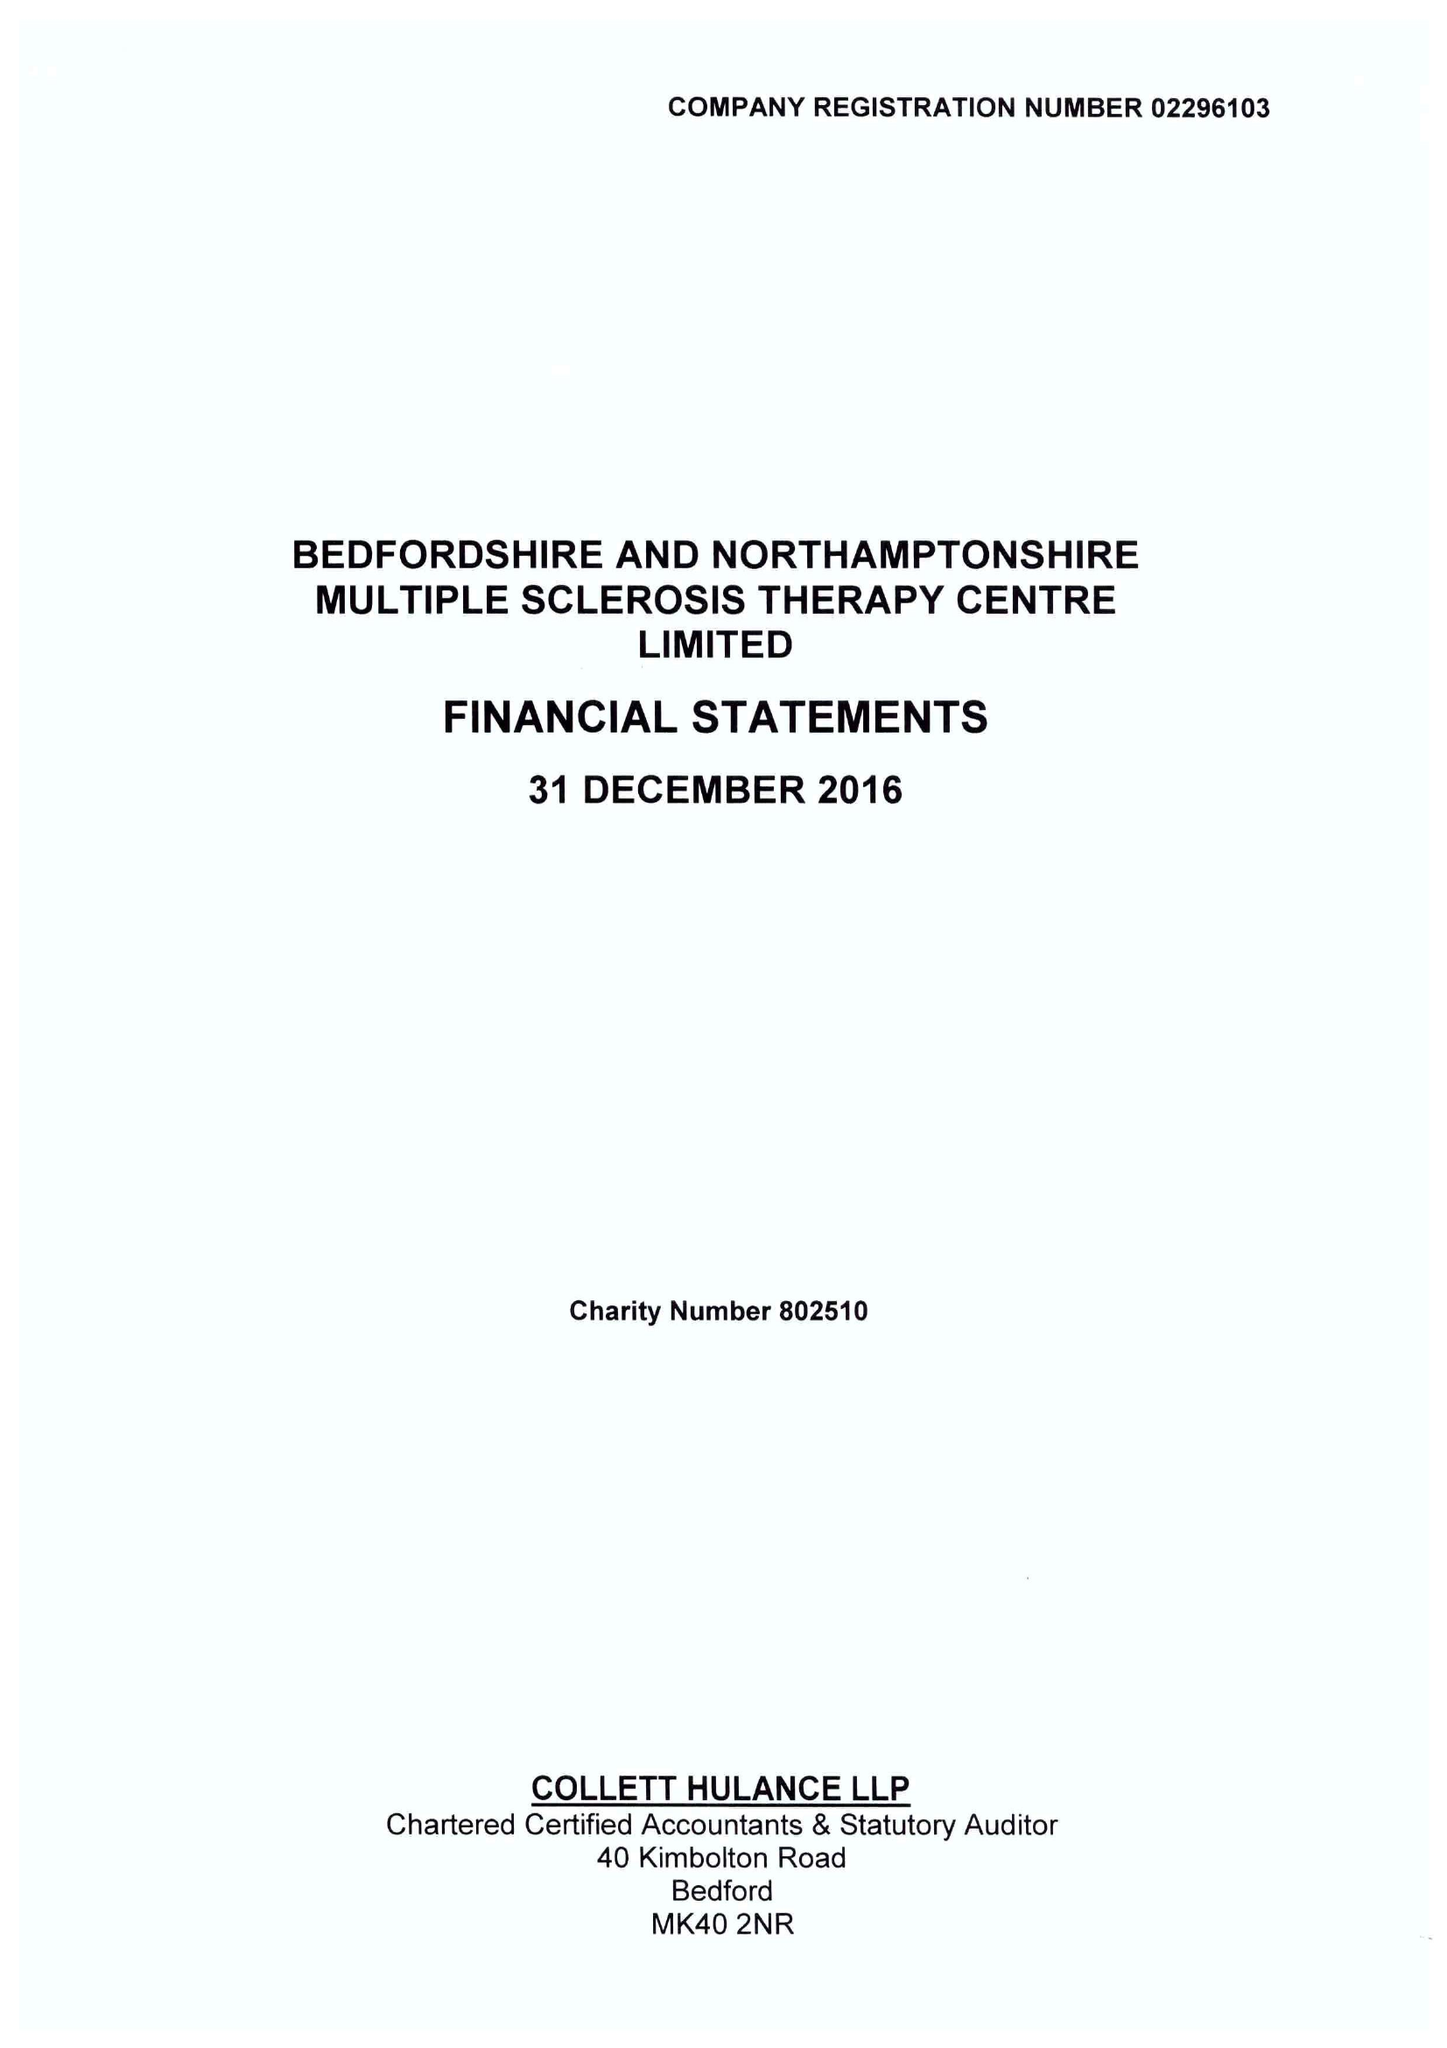What is the value for the spending_annually_in_british_pounds?
Answer the question using a single word or phrase. 394979.00 